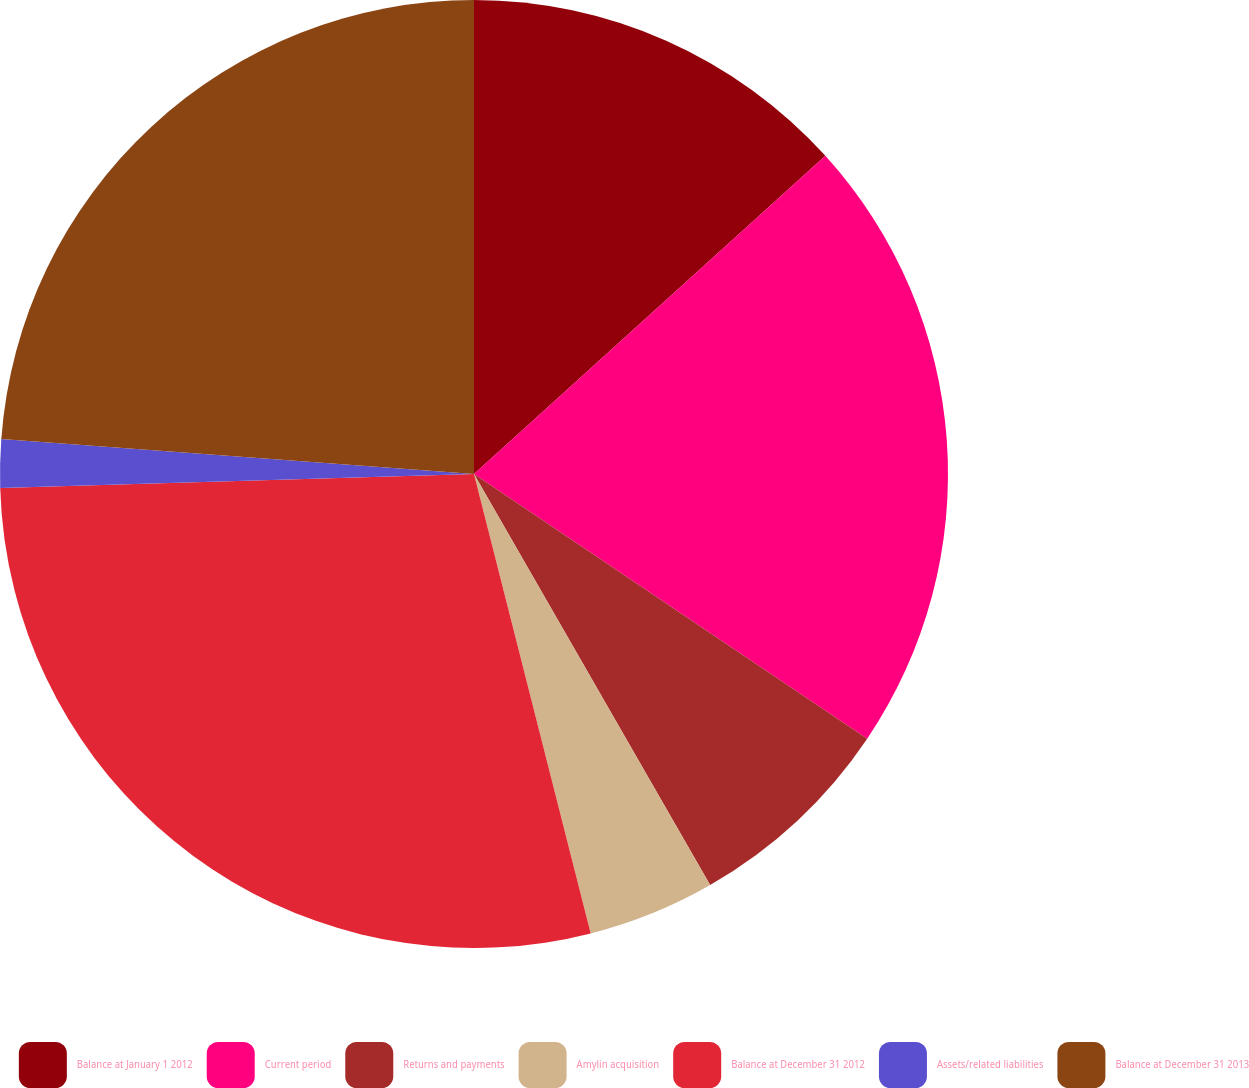Convert chart to OTSL. <chart><loc_0><loc_0><loc_500><loc_500><pie_chart><fcel>Balance at January 1 2012<fcel>Current period<fcel>Returns and payments<fcel>Amylin acquisition<fcel>Balance at December 31 2012<fcel>Assets/related liabilities<fcel>Balance at December 31 2013<nl><fcel>13.29%<fcel>21.14%<fcel>7.27%<fcel>4.34%<fcel>28.49%<fcel>1.65%<fcel>23.82%<nl></chart> 